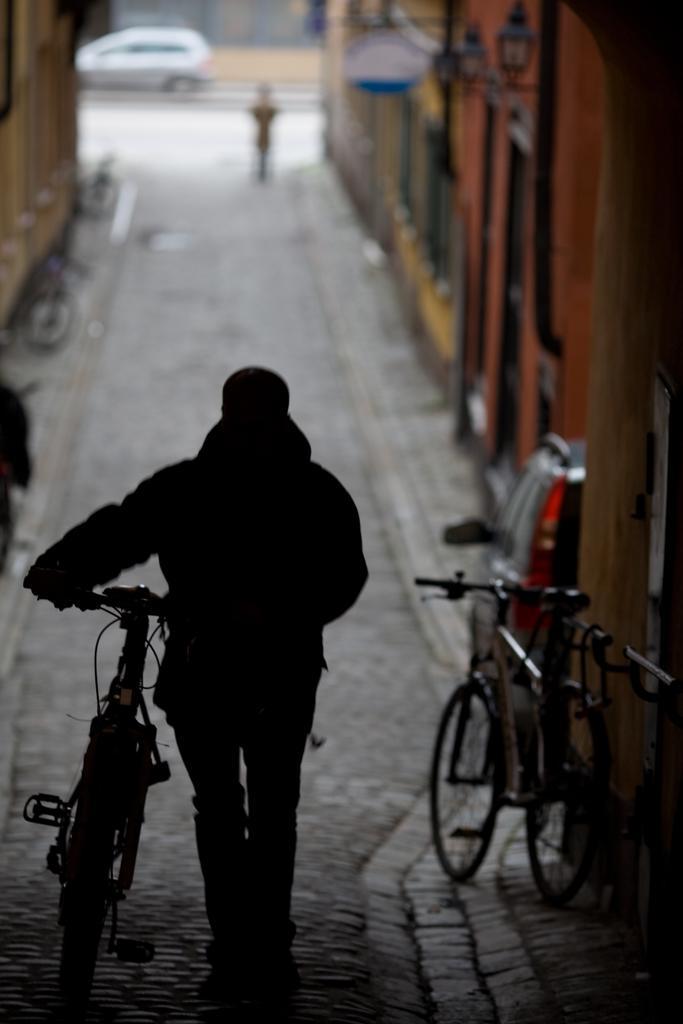Describe this image in one or two sentences. In the image there is a person walking in middle of street along with bicycle, there are buildings on either side of the road, on the right side there is a car and cycle in front of the building, in the background there is a car going on the road. 